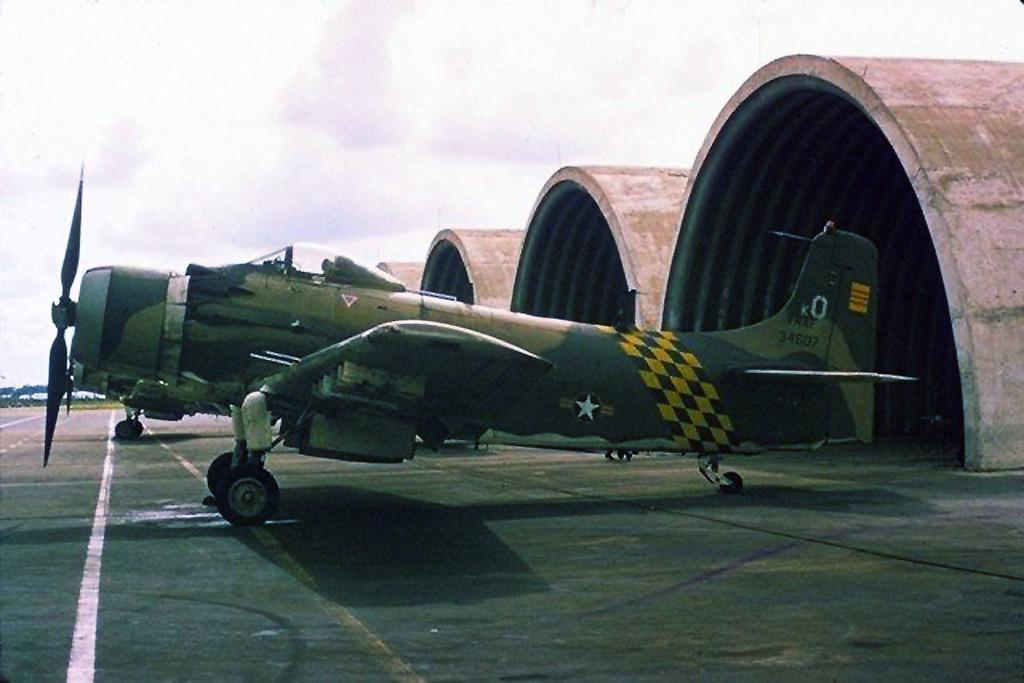<image>
Give a short and clear explanation of the subsequent image. An old fighter airplane is outside of the hangers and it has a number 0 on its tail wing. 